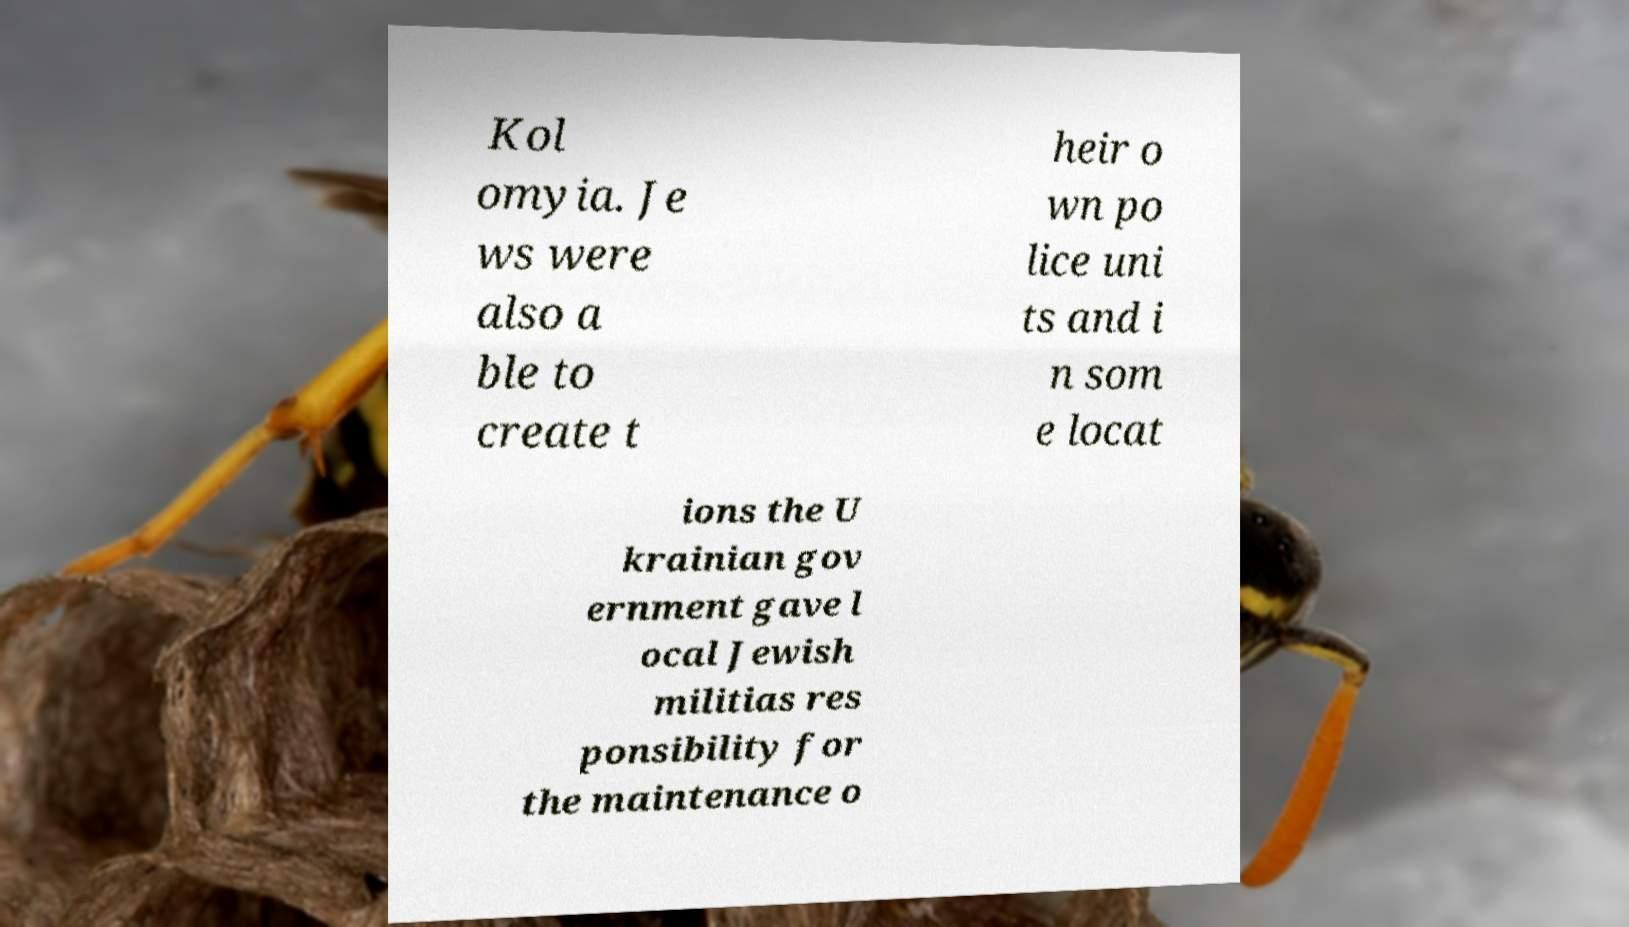I need the written content from this picture converted into text. Can you do that? Kol omyia. Je ws were also a ble to create t heir o wn po lice uni ts and i n som e locat ions the U krainian gov ernment gave l ocal Jewish militias res ponsibility for the maintenance o 